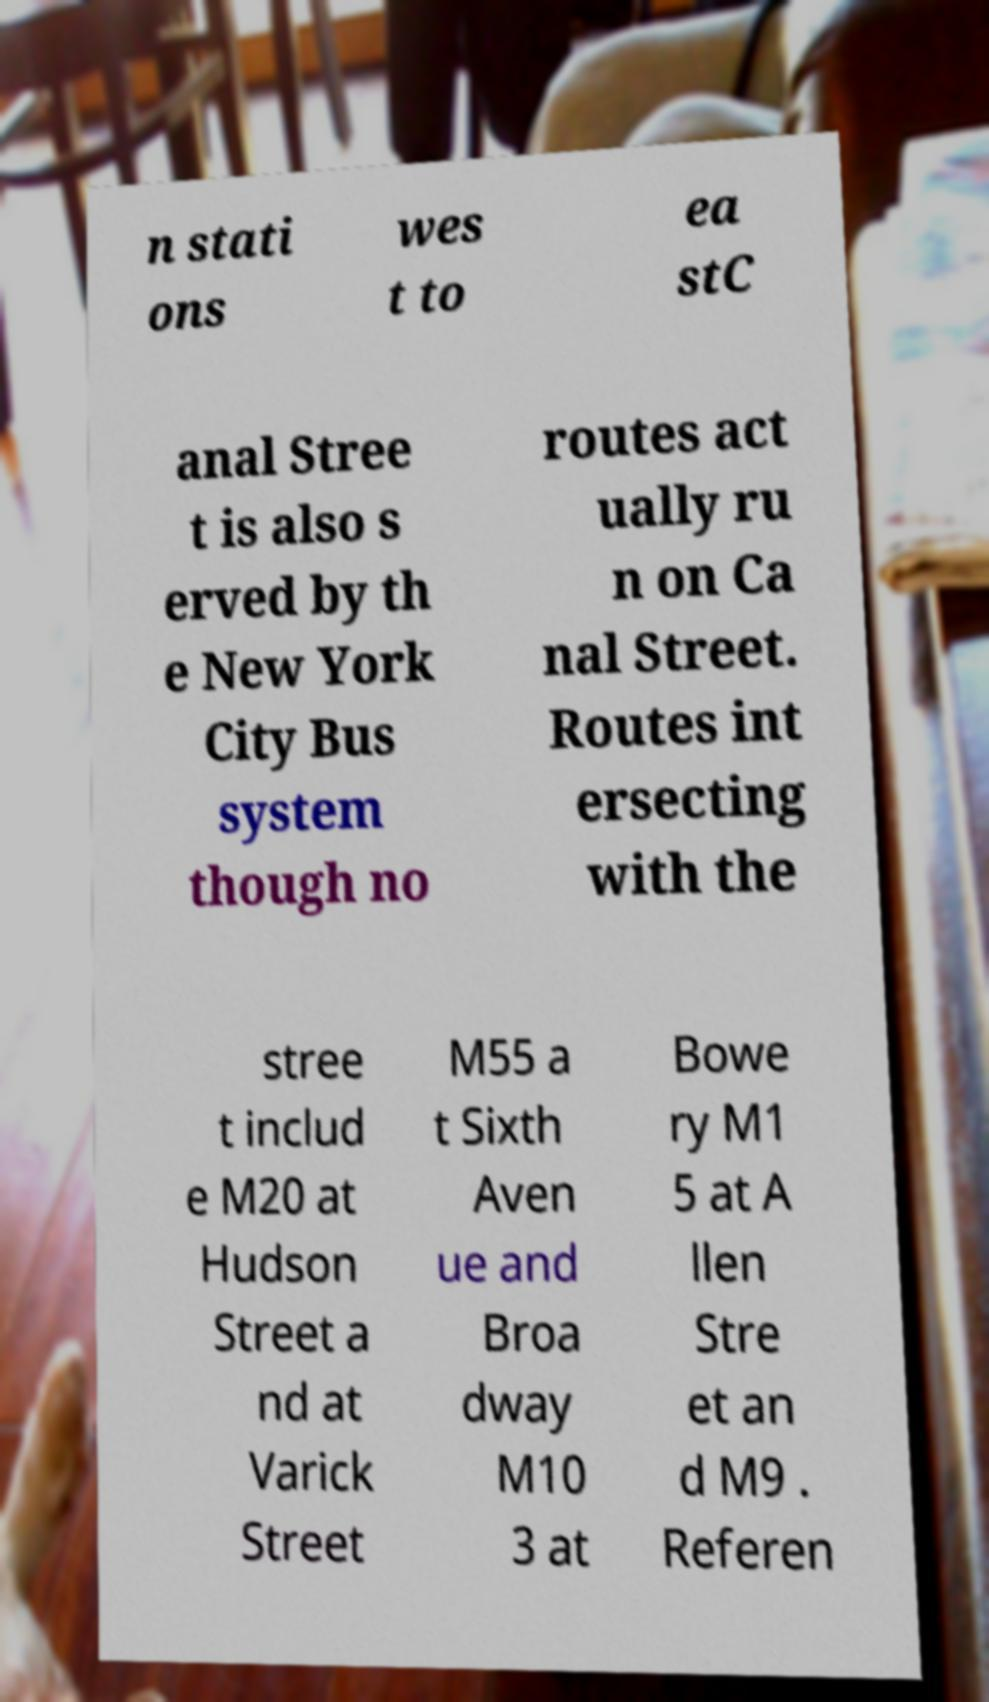Could you assist in decoding the text presented in this image and type it out clearly? n stati ons wes t to ea stC anal Stree t is also s erved by th e New York City Bus system though no routes act ually ru n on Ca nal Street. Routes int ersecting with the stree t includ e M20 at Hudson Street a nd at Varick Street M55 a t Sixth Aven ue and Broa dway M10 3 at Bowe ry M1 5 at A llen Stre et an d M9 . Referen 